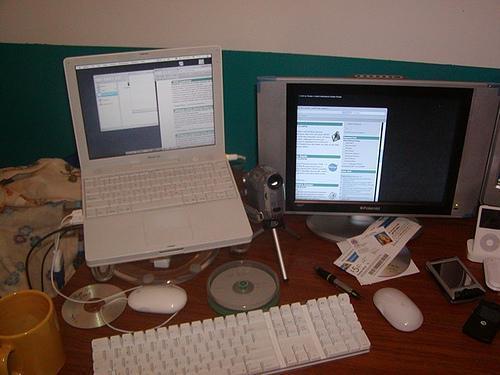How many computers are on?
Give a very brief answer. 2. How many computer keyboards?
Give a very brief answer. 2. How many keyboards can you see?
Give a very brief answer. 2. How many laptops are there?
Give a very brief answer. 1. 